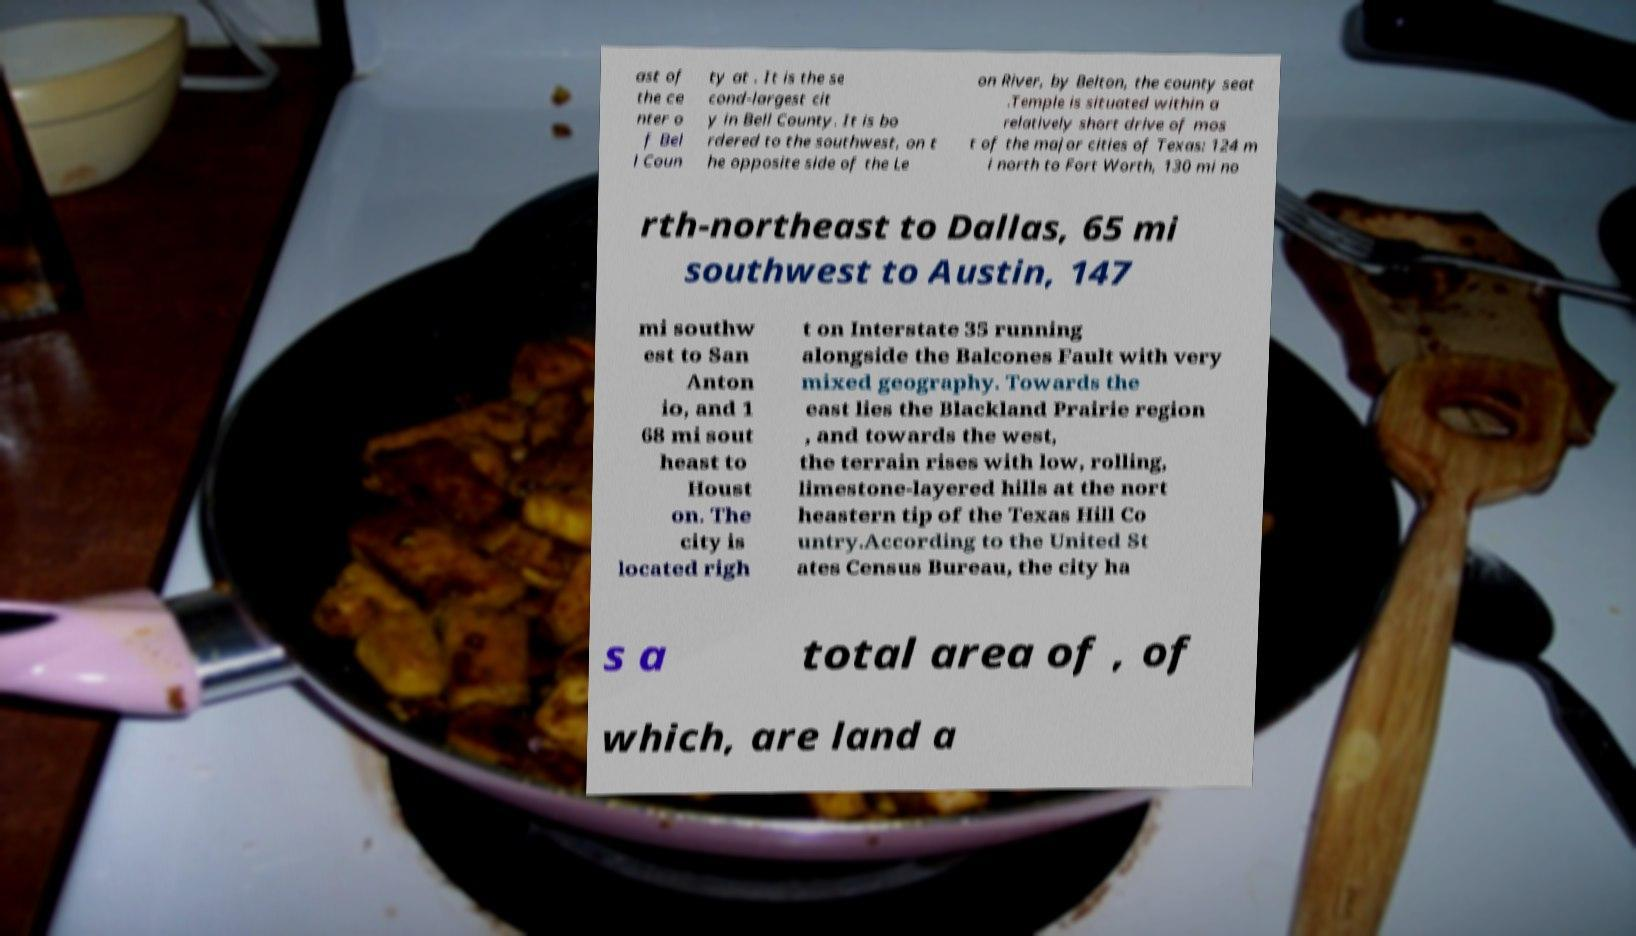Please read and relay the text visible in this image. What does it say? ast of the ce nter o f Bel l Coun ty at . It is the se cond-largest cit y in Bell County. It is bo rdered to the southwest, on t he opposite side of the Le on River, by Belton, the county seat .Temple is situated within a relatively short drive of mos t of the major cities of Texas: 124 m i north to Fort Worth, 130 mi no rth-northeast to Dallas, 65 mi southwest to Austin, 147 mi southw est to San Anton io, and 1 68 mi sout heast to Houst on. The city is located righ t on Interstate 35 running alongside the Balcones Fault with very mixed geography. Towards the east lies the Blackland Prairie region , and towards the west, the terrain rises with low, rolling, limestone-layered hills at the nort heastern tip of the Texas Hill Co untry.According to the United St ates Census Bureau, the city ha s a total area of , of which, are land a 